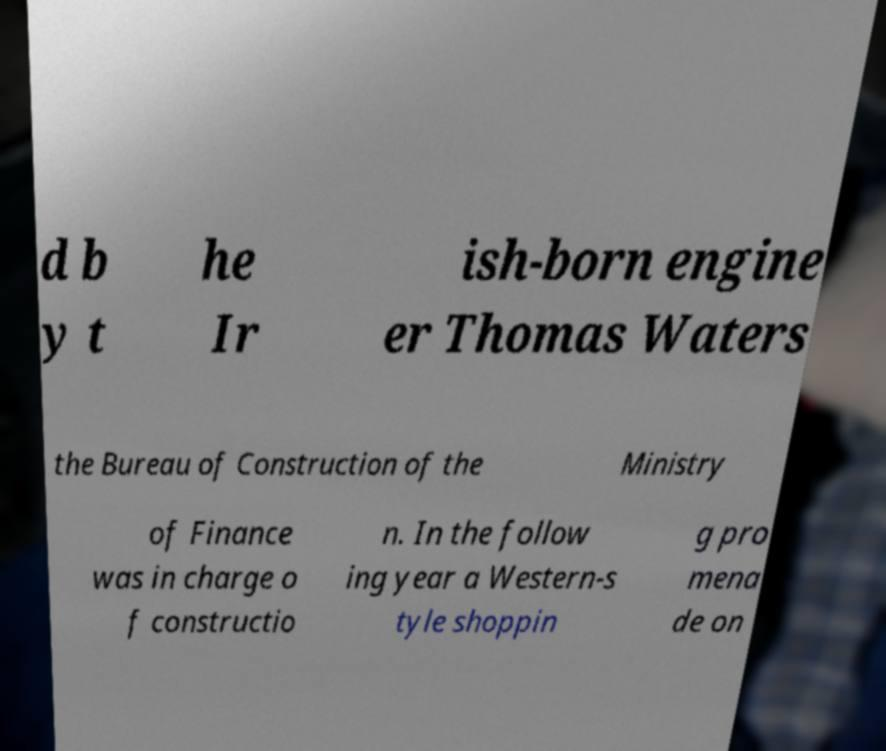What messages or text are displayed in this image? I need them in a readable, typed format. d b y t he Ir ish-born engine er Thomas Waters the Bureau of Construction of the Ministry of Finance was in charge o f constructio n. In the follow ing year a Western-s tyle shoppin g pro mena de on 